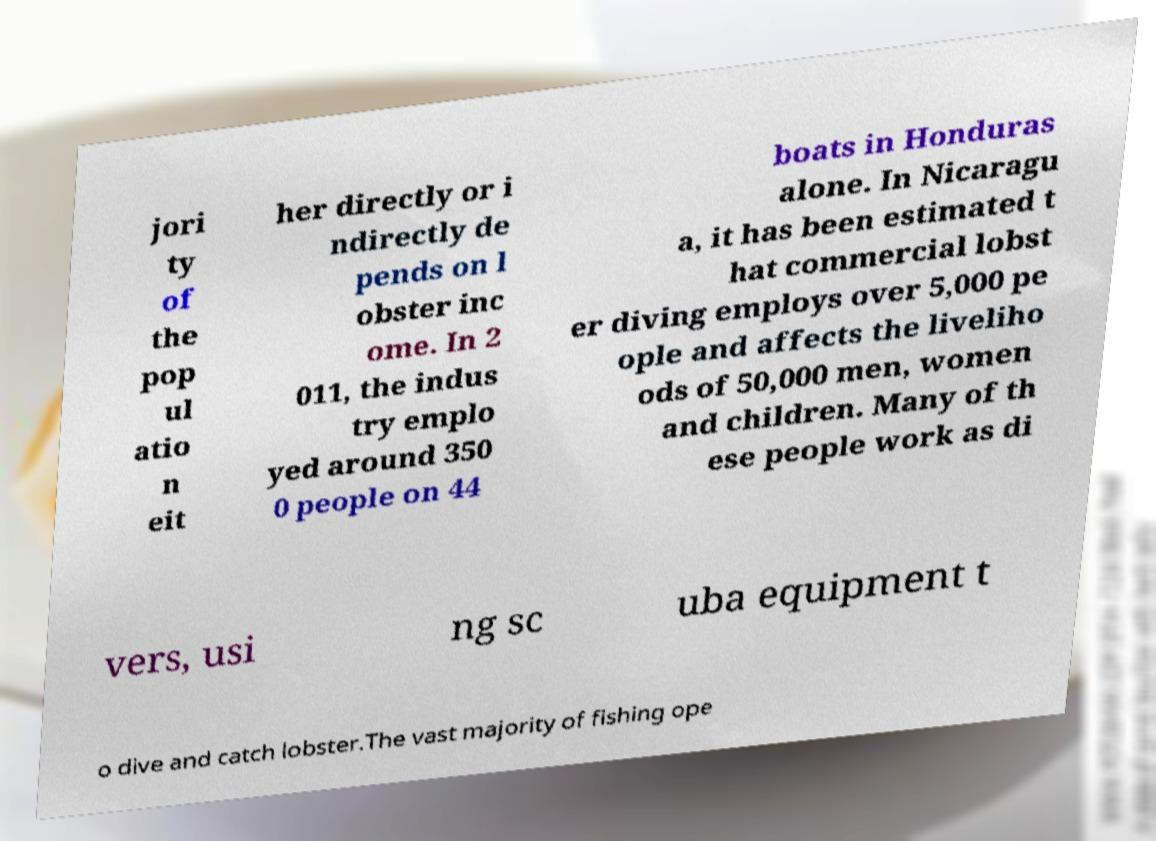Could you extract and type out the text from this image? jori ty of the pop ul atio n eit her directly or i ndirectly de pends on l obster inc ome. In 2 011, the indus try emplo yed around 350 0 people on 44 boats in Honduras alone. In Nicaragu a, it has been estimated t hat commercial lobst er diving employs over 5,000 pe ople and affects the liveliho ods of 50,000 men, women and children. Many of th ese people work as di vers, usi ng sc uba equipment t o dive and catch lobster.The vast majority of fishing ope 